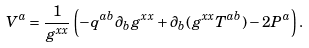<formula> <loc_0><loc_0><loc_500><loc_500>V ^ { a } = \frac { 1 } { g ^ { x x } } \left ( - q ^ { a b } \partial _ { b } g ^ { x x } + \partial _ { b } ( g ^ { x x } T ^ { a b } ) - 2 P ^ { a } \right ) .</formula> 